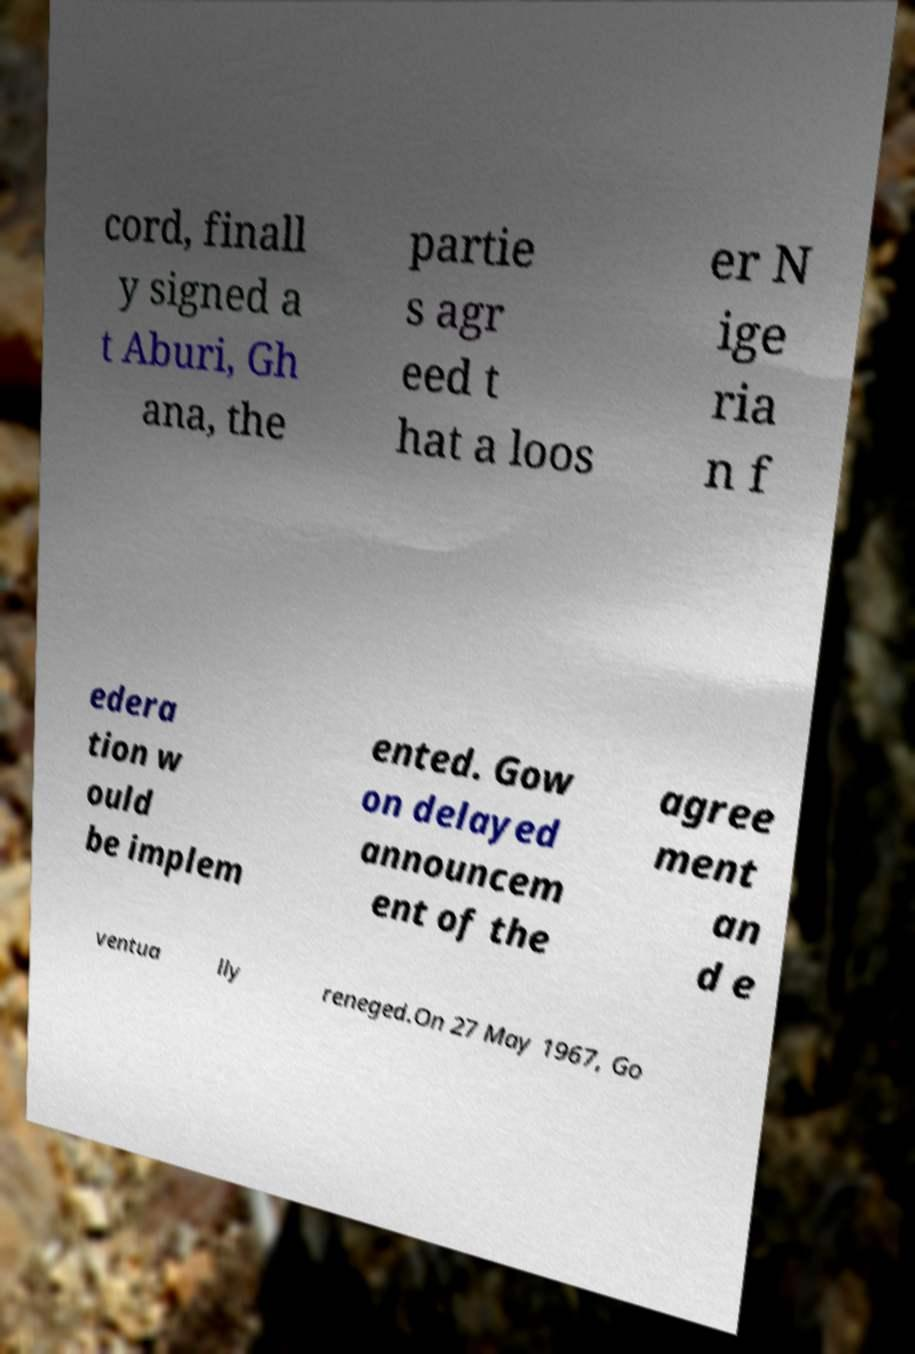I need the written content from this picture converted into text. Can you do that? cord, finall y signed a t Aburi, Gh ana, the partie s agr eed t hat a loos er N ige ria n f edera tion w ould be implem ented. Gow on delayed announcem ent of the agree ment an d e ventua lly reneged.On 27 May 1967, Go 